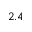Convert formula to latex. <formula><loc_0><loc_0><loc_500><loc_500>2 . 4</formula> 